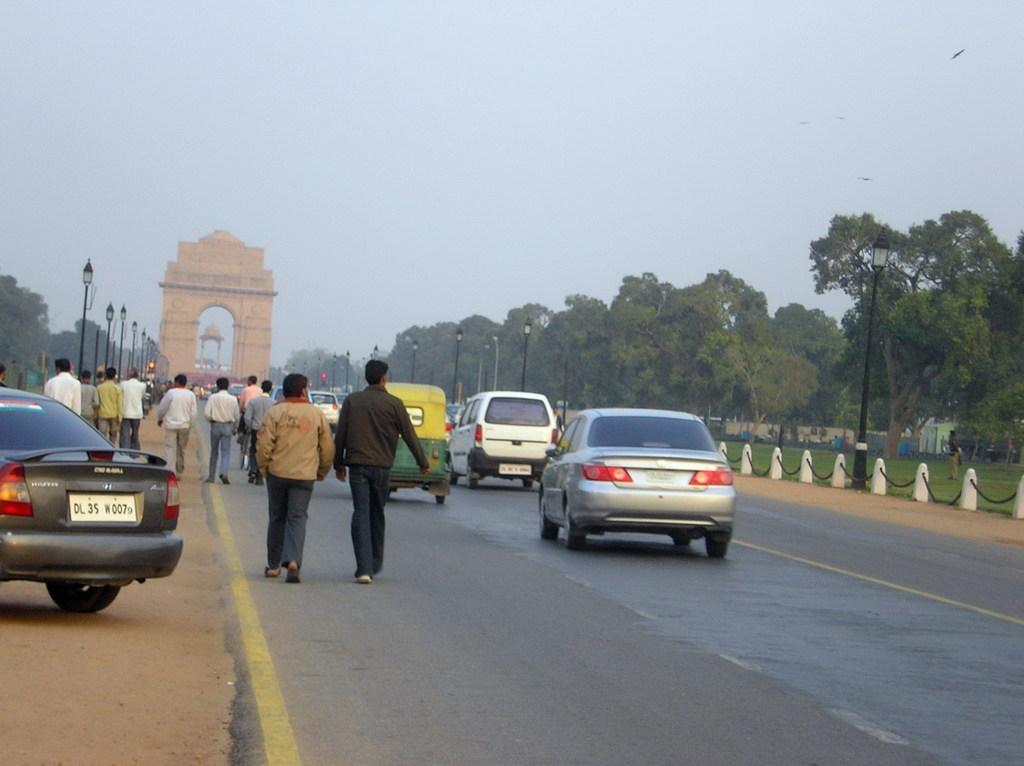Could you give a brief overview of what you see in this image? In this image we can see some persons walking on the road there are some vehicles moving on the road and on right side of the image there are some trees, garden area and in the background of the image there is India gate and there are some lights. 